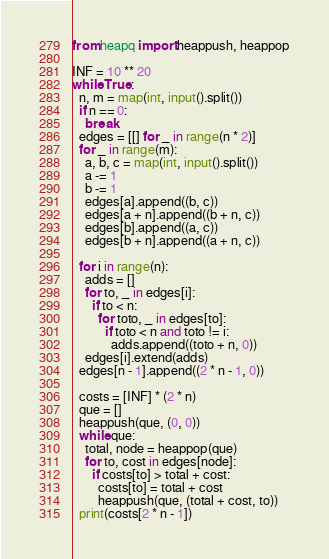Convert code to text. <code><loc_0><loc_0><loc_500><loc_500><_Python_>from heapq import heappush, heappop

INF = 10 ** 20
while True:
  n, m = map(int, input().split())
  if n == 0:
    break
  edges = [[] for _ in range(n * 2)]
  for _ in range(m):
    a, b, c = map(int, input().split())
    a -= 1
    b -= 1
    edges[a].append((b, c))
    edges[a + n].append((b + n, c))
    edges[b].append((a, c))
    edges[b + n].append((a + n, c))
  
  for i in range(n):
    adds = []
    for to, _ in edges[i]:
      if to < n:
        for toto, _ in edges[to]:
          if toto < n and toto != i:
            adds.append((toto + n, 0))
    edges[i].extend(adds)
  edges[n - 1].append((2 * n - 1, 0))
  
  costs = [INF] * (2 * n)
  que = []
  heappush(que, (0, 0))
  while que:
    total, node = heappop(que)
    for to, cost in edges[node]:
      if costs[to] > total + cost:
        costs[to] = total + cost
        heappush(que, (total + cost, to))
  print(costs[2 * n - 1])
</code> 